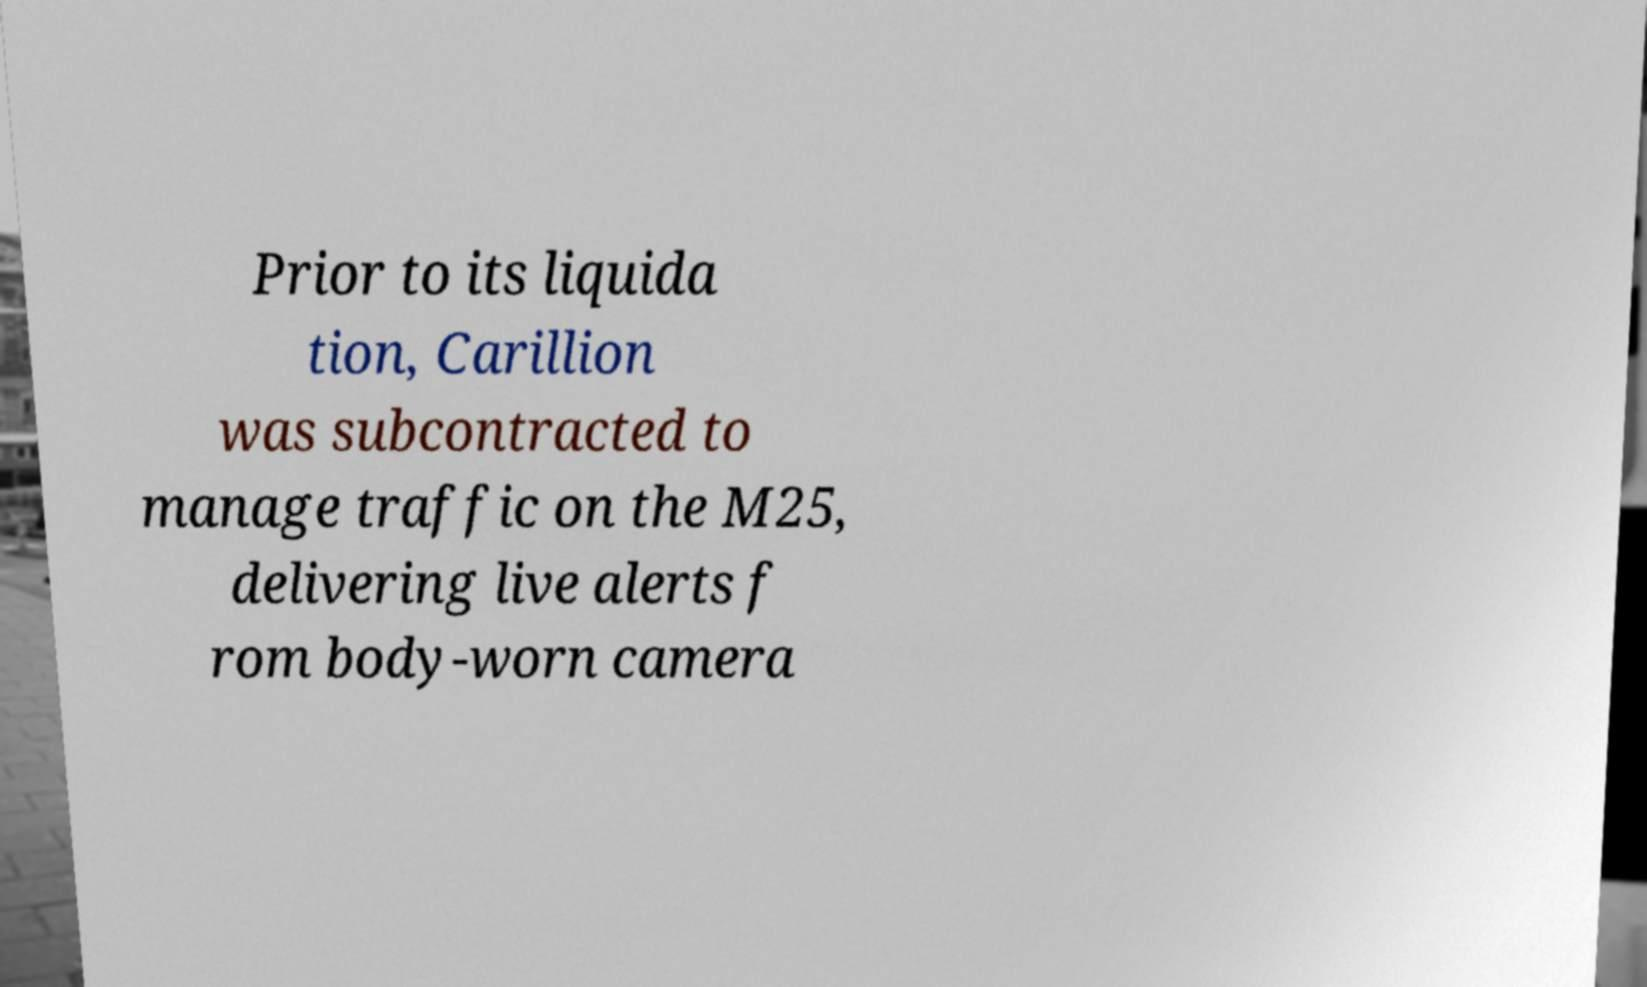There's text embedded in this image that I need extracted. Can you transcribe it verbatim? Prior to its liquida tion, Carillion was subcontracted to manage traffic on the M25, delivering live alerts f rom body-worn camera 